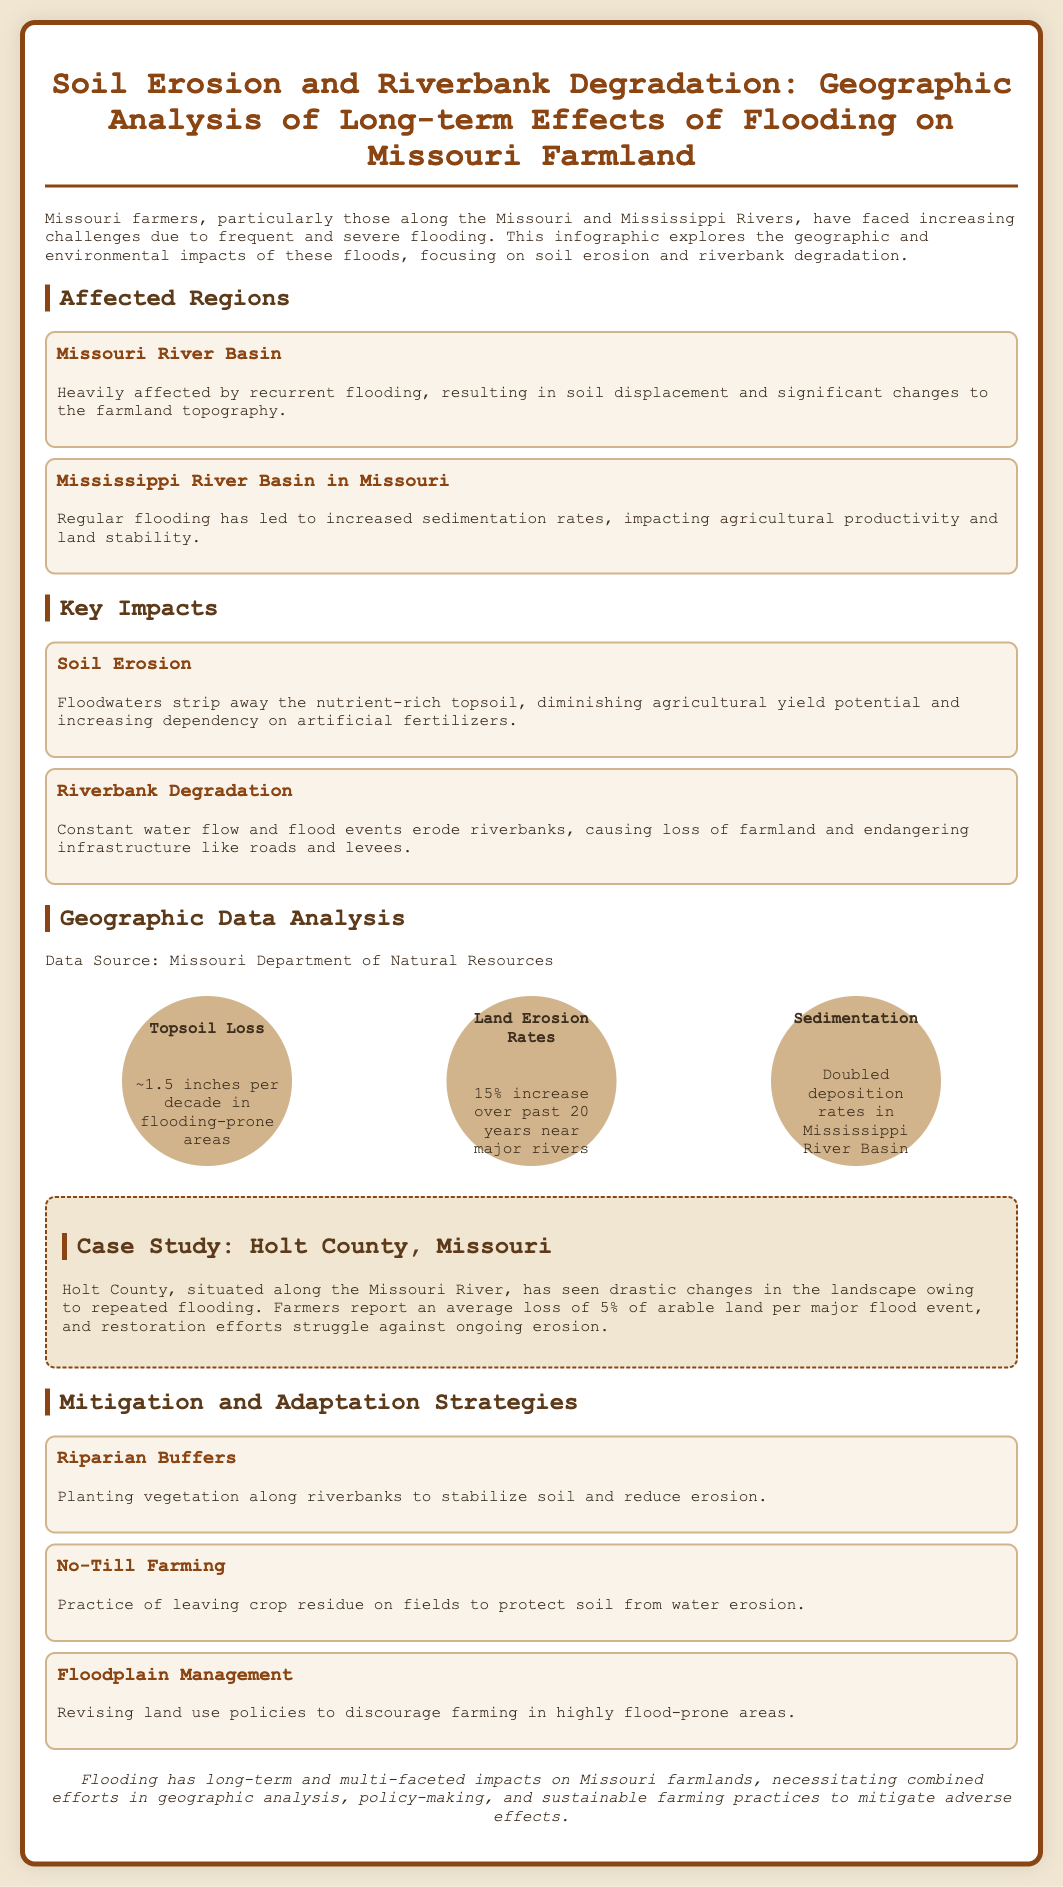What is the document about? The document provides a geographic analysis of long-term effects of flooding on Missouri farmland, focusing on soil erosion and riverbank degradation.
Answer: Soil Erosion and Riverbank Degradation What is the average topsoil loss per decade? The average topsoil loss is mentioned in the data analysis section, which specifically states "~1.5 inches per decade in flooding-prone areas."
Answer: ~1.5 inches What has been the land erosion rate increase over the past 20 years? The document states that there has been a "15% increase over past 20 years near major rivers."
Answer: 15% Which two river basins are heavily affected by flooding? The infographic lists two impacted regions related to flooding: Missouri River Basin and Mississippi River Basin in Missouri.
Answer: Missouri River Basin, Mississippi River Basin in Missouri What mitigation strategy involves planting vegetation? The document lists 'Riparian Buffers' as one strategy which involves planting vegetation along riverbanks.
Answer: Riparian Buffers How much arable land is lost per major flood event in Holt County? According to the case study, farmers in Holt County report an average loss of "5% of arable land per major flood event."
Answer: 5% What has happened to sedimentation rates in the Mississippi River Basin? The data analysis section indicates that sedimentation rates have "doubled deposition rates in Mississippi River Basin."
Answer: Doubled What type of farming practice is suggested to protect soil? The document mentions "No-Till Farming" as a practice that protects soil from water erosion.
Answer: No-Till Farming What is the conclusion regarding the impact of flooding on farmlands? The conclusion summarizes that flooding has "long-term and multi-faceted impacts on Missouri farmlands."
Answer: Long-term and multi-faceted impacts 